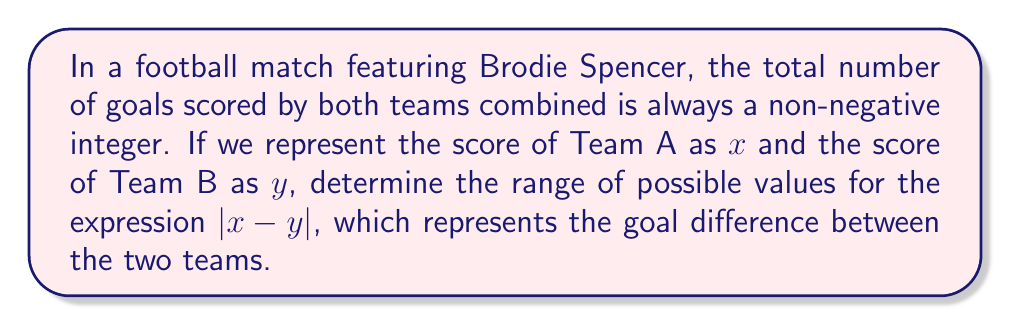Could you help me with this problem? Let's approach this step-by-step:

1) First, we know that $x$ and $y$ are non-negative integers, as teams cannot score a negative number of goals.

2) The expression $|x - y|$ represents the absolute difference between the scores, which is always a non-negative integer.

3) The minimum value of $|x - y|$ occurs when both teams have the same score:
   If $x = y$, then $|x - y| = 0$

4) The maximum value of $|x - y|$ is theoretically unbounded, as there's no upper limit to how many goals a team can score. However, in practical terms, football matches rarely see extremely high scores.

5) To express this as an inequality:

   $$ 0 \leq |x - y| < \infty $$

6) Since we're dealing with integers, we can express this more precisely as:

   $$ |x - y| \in \{0, 1, 2, 3, ...\} $$

   This means $|x - y|$ can be any non-negative integer.
Answer: $|x - y| \in \mathbb{N}_0$ 